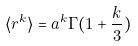Convert formula to latex. <formula><loc_0><loc_0><loc_500><loc_500>\langle r ^ { k } \rangle = a ^ { k } \Gamma ( 1 + \frac { k } { 3 } )</formula> 